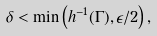<formula> <loc_0><loc_0><loc_500><loc_500>\delta < \min \left ( h ^ { - 1 } ( \Gamma ) , \epsilon / 2 \right ) ,</formula> 